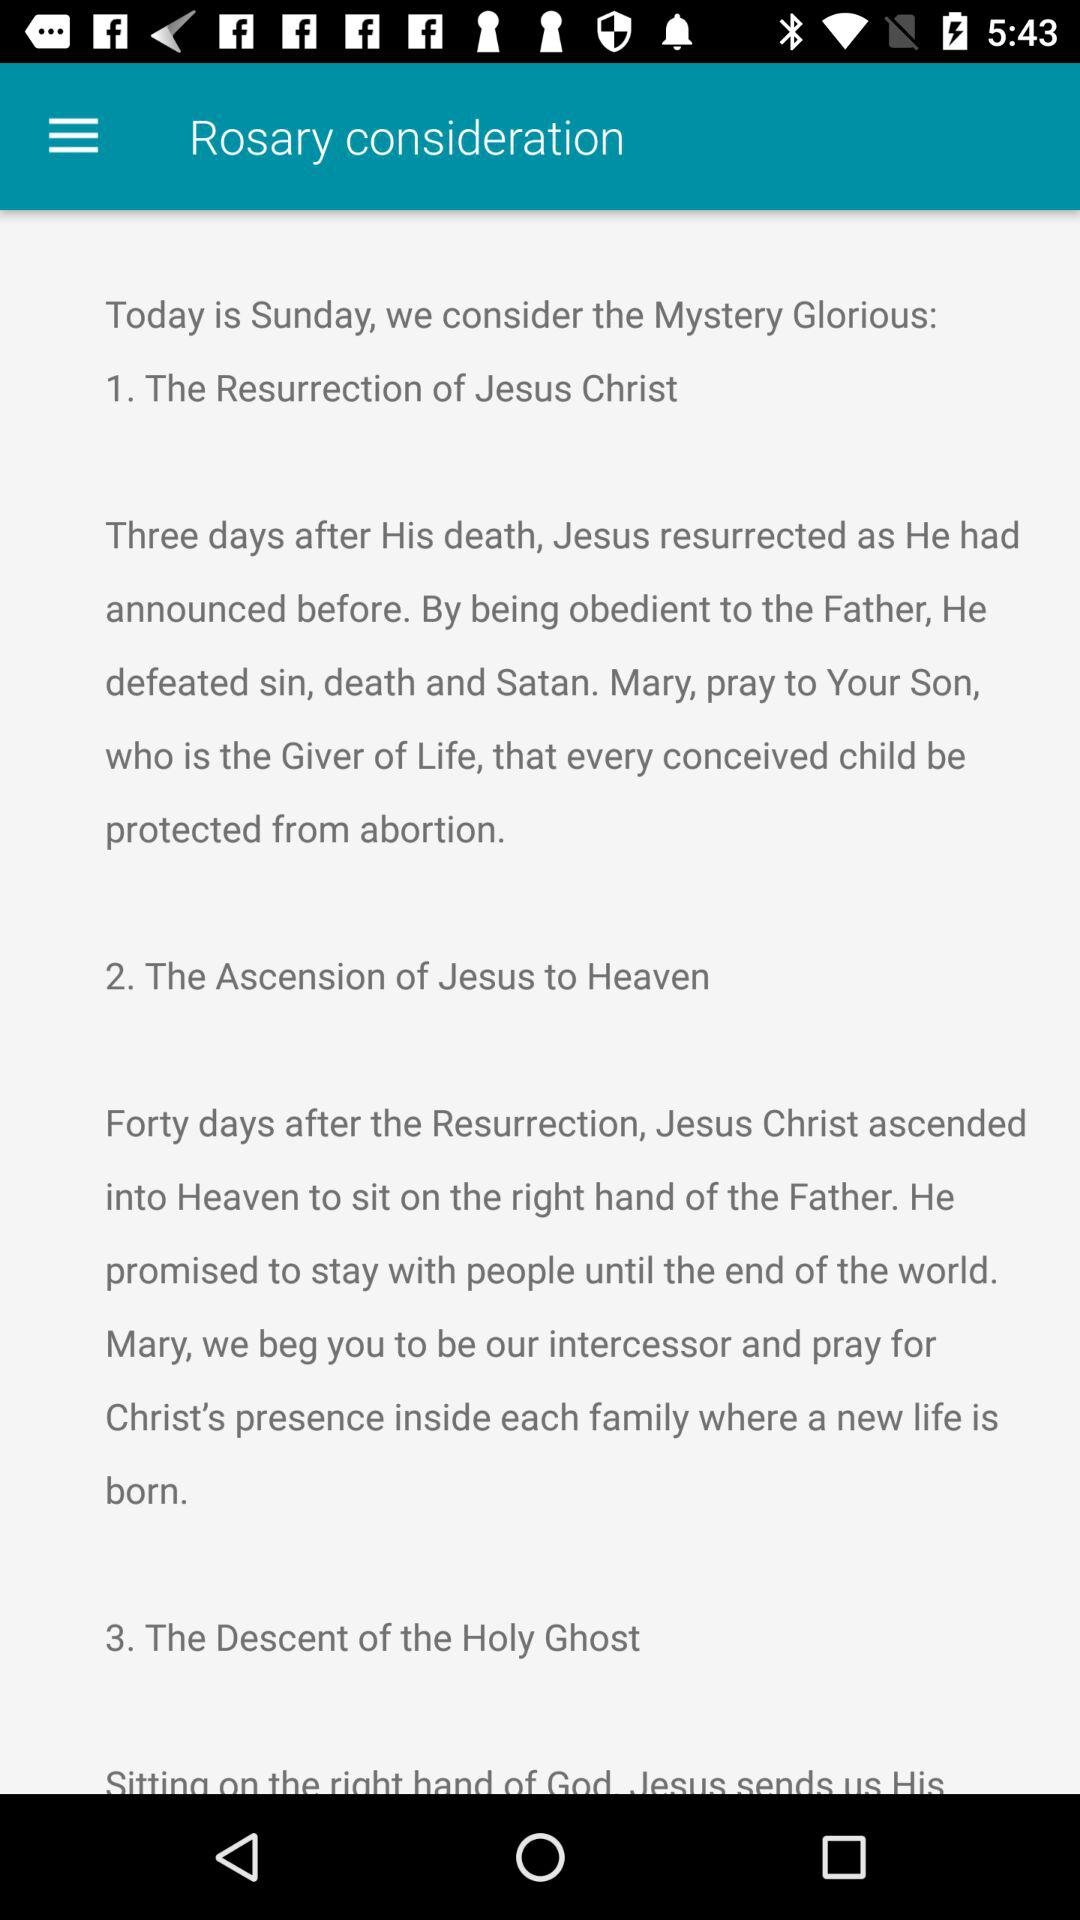How many mysteries are there?
Answer the question using a single word or phrase. 3 